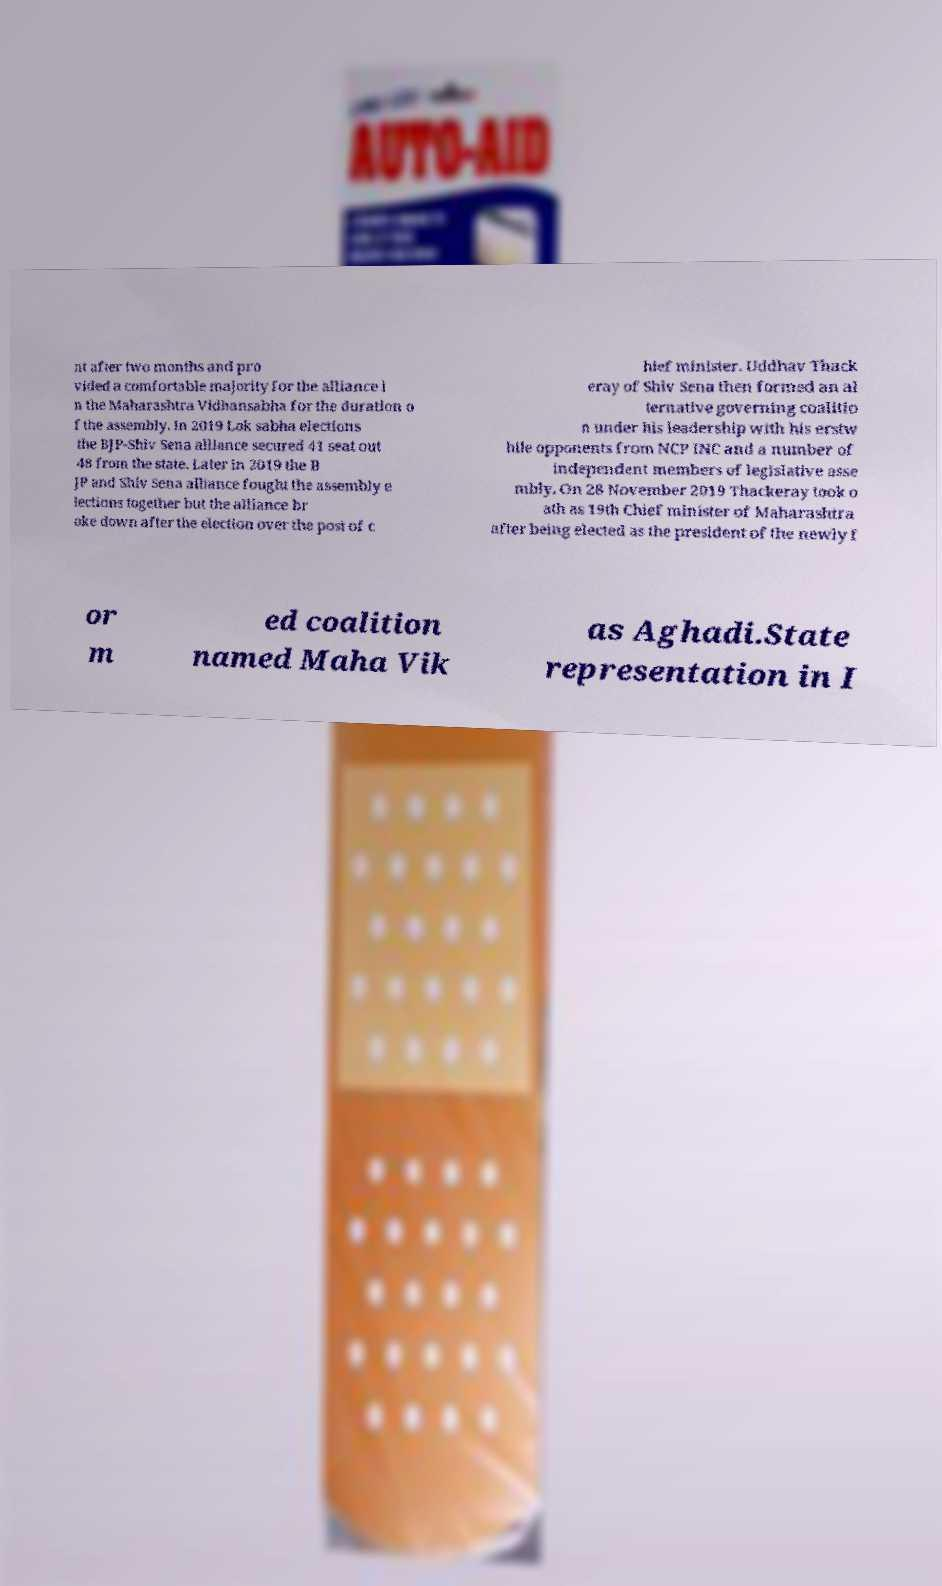For documentation purposes, I need the text within this image transcribed. Could you provide that? nt after two months and pro vided a comfortable majority for the alliance i n the Maharashtra Vidhansabha for the duration o f the assembly. In 2019 Lok sabha elections the BJP-Shiv Sena alliance secured 41 seat out 48 from the state. Later in 2019 the B JP and Shiv Sena alliance fought the assembly e lections together but the alliance br oke down after the election over the post of c hief minister. Uddhav Thack eray of Shiv Sena then formed an al ternative governing coalitio n under his leadership with his erstw hile opponents from NCP INC and a number of independent members of legislative asse mbly. On 28 November 2019 Thackeray took o ath as 19th Chief minister of Maharashtra after being elected as the president of the newly f or m ed coalition named Maha Vik as Aghadi.State representation in I 